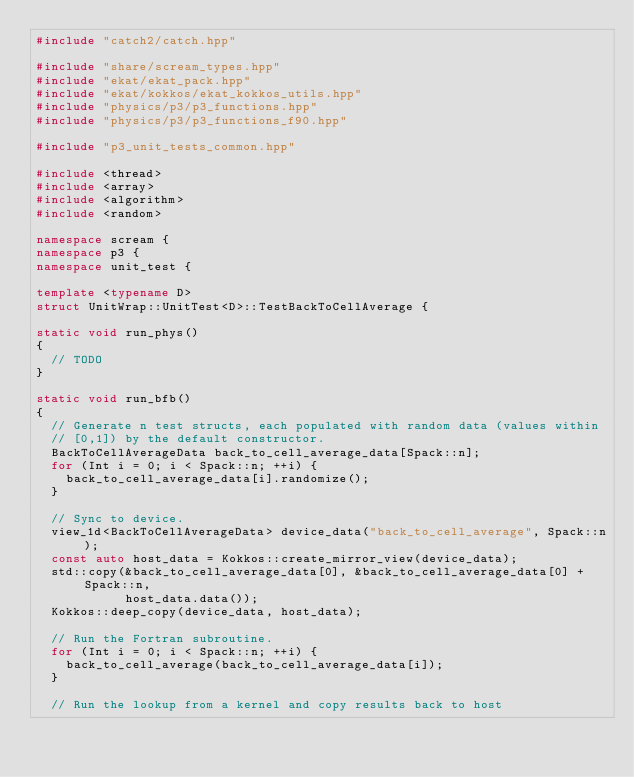<code> <loc_0><loc_0><loc_500><loc_500><_C++_>#include "catch2/catch.hpp"

#include "share/scream_types.hpp"
#include "ekat/ekat_pack.hpp"
#include "ekat/kokkos/ekat_kokkos_utils.hpp"
#include "physics/p3/p3_functions.hpp"
#include "physics/p3/p3_functions_f90.hpp"

#include "p3_unit_tests_common.hpp"

#include <thread>
#include <array>
#include <algorithm>
#include <random>

namespace scream {
namespace p3 {
namespace unit_test {

template <typename D>
struct UnitWrap::UnitTest<D>::TestBackToCellAverage {

static void run_phys()
{
  // TODO
}

static void run_bfb()
{
  // Generate n test structs, each populated with random data (values within
  // [0,1]) by the default constructor.
  BackToCellAverageData back_to_cell_average_data[Spack::n];
  for (Int i = 0; i < Spack::n; ++i) {
    back_to_cell_average_data[i].randomize();
  }

  // Sync to device.
  view_1d<BackToCellAverageData> device_data("back_to_cell_average", Spack::n);
  const auto host_data = Kokkos::create_mirror_view(device_data);
  std::copy(&back_to_cell_average_data[0], &back_to_cell_average_data[0] + Spack::n,
            host_data.data());
  Kokkos::deep_copy(device_data, host_data);

  // Run the Fortran subroutine.
  for (Int i = 0; i < Spack::n; ++i) {
    back_to_cell_average(back_to_cell_average_data[i]);
  }

  // Run the lookup from a kernel and copy results back to host</code> 